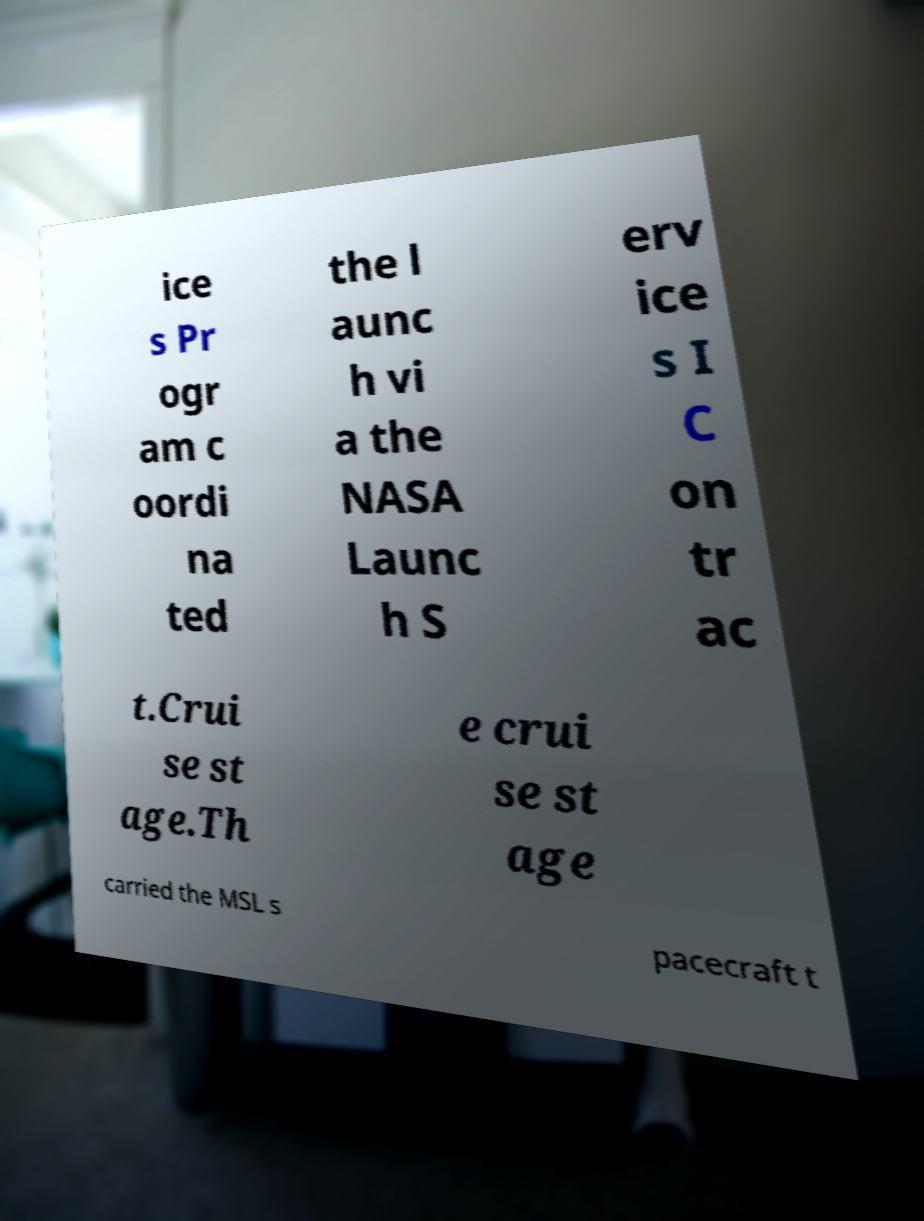Can you accurately transcribe the text from the provided image for me? ice s Pr ogr am c oordi na ted the l aunc h vi a the NASA Launc h S erv ice s I C on tr ac t.Crui se st age.Th e crui se st age carried the MSL s pacecraft t 